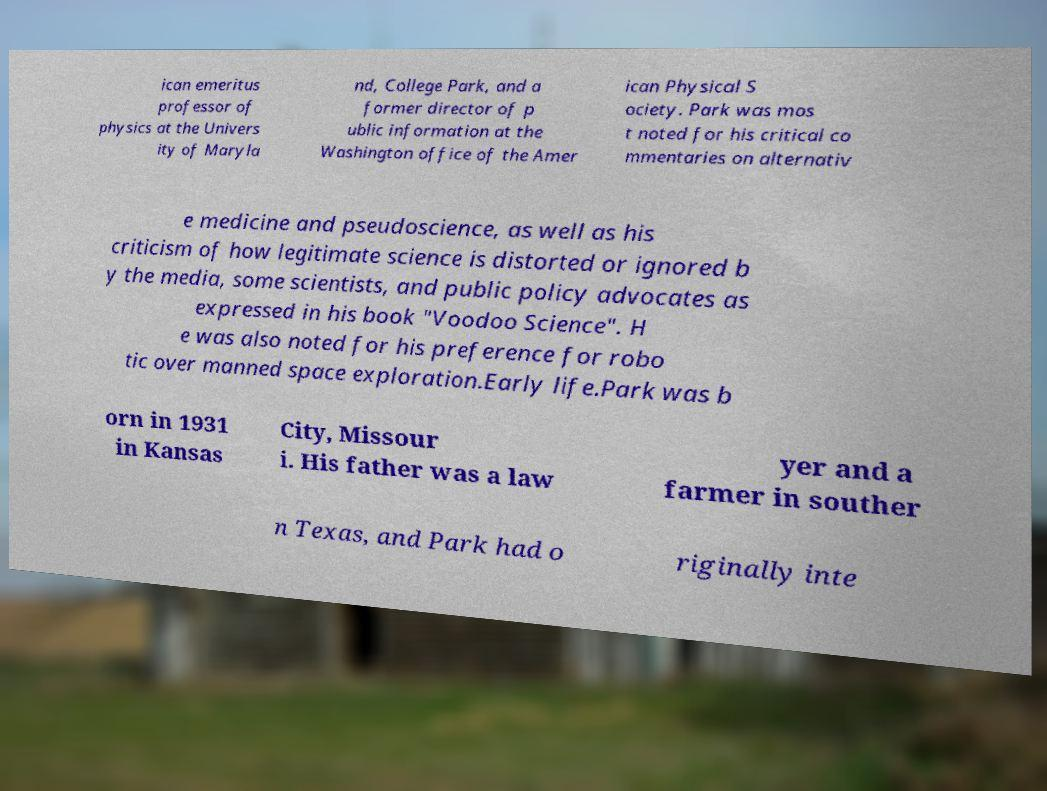Please identify and transcribe the text found in this image. ican emeritus professor of physics at the Univers ity of Maryla nd, College Park, and a former director of p ublic information at the Washington office of the Amer ican Physical S ociety. Park was mos t noted for his critical co mmentaries on alternativ e medicine and pseudoscience, as well as his criticism of how legitimate science is distorted or ignored b y the media, some scientists, and public policy advocates as expressed in his book "Voodoo Science". H e was also noted for his preference for robo tic over manned space exploration.Early life.Park was b orn in 1931 in Kansas City, Missour i. His father was a law yer and a farmer in souther n Texas, and Park had o riginally inte 